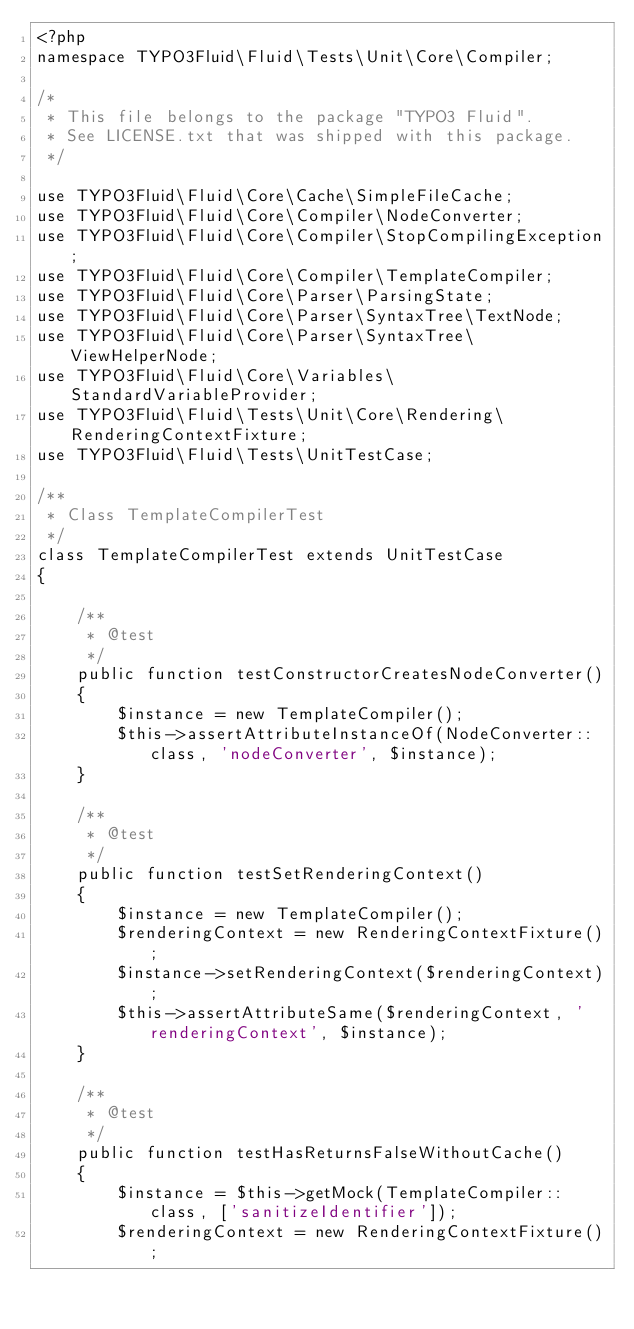<code> <loc_0><loc_0><loc_500><loc_500><_PHP_><?php
namespace TYPO3Fluid\Fluid\Tests\Unit\Core\Compiler;

/*
 * This file belongs to the package "TYPO3 Fluid".
 * See LICENSE.txt that was shipped with this package.
 */

use TYPO3Fluid\Fluid\Core\Cache\SimpleFileCache;
use TYPO3Fluid\Fluid\Core\Compiler\NodeConverter;
use TYPO3Fluid\Fluid\Core\Compiler\StopCompilingException;
use TYPO3Fluid\Fluid\Core\Compiler\TemplateCompiler;
use TYPO3Fluid\Fluid\Core\Parser\ParsingState;
use TYPO3Fluid\Fluid\Core\Parser\SyntaxTree\TextNode;
use TYPO3Fluid\Fluid\Core\Parser\SyntaxTree\ViewHelperNode;
use TYPO3Fluid\Fluid\Core\Variables\StandardVariableProvider;
use TYPO3Fluid\Fluid\Tests\Unit\Core\Rendering\RenderingContextFixture;
use TYPO3Fluid\Fluid\Tests\UnitTestCase;

/**
 * Class TemplateCompilerTest
 */
class TemplateCompilerTest extends UnitTestCase
{

    /**
     * @test
     */
    public function testConstructorCreatesNodeConverter()
    {
        $instance = new TemplateCompiler();
        $this->assertAttributeInstanceOf(NodeConverter::class, 'nodeConverter', $instance);
    }

    /**
     * @test
     */
    public function testSetRenderingContext()
    {
        $instance = new TemplateCompiler();
        $renderingContext = new RenderingContextFixture();
        $instance->setRenderingContext($renderingContext);
        $this->assertAttributeSame($renderingContext, 'renderingContext', $instance);
    }

    /**
     * @test
     */
    public function testHasReturnsFalseWithoutCache()
    {
        $instance = $this->getMock(TemplateCompiler::class, ['sanitizeIdentifier']);
        $renderingContext = new RenderingContextFixture();</code> 